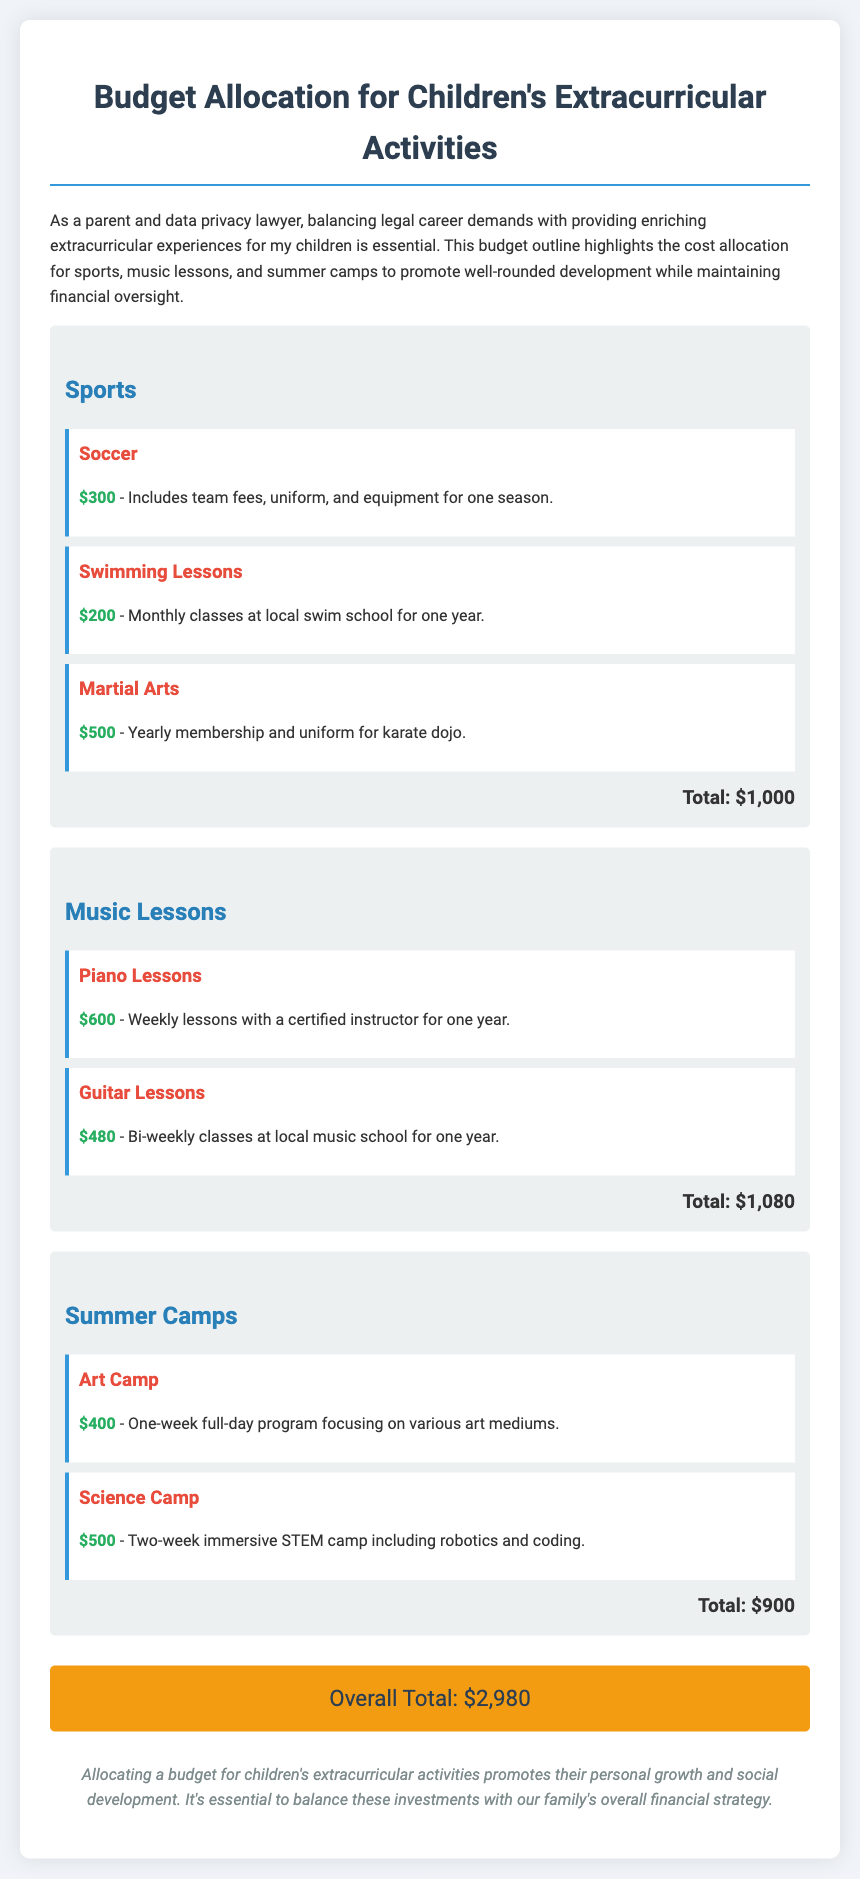What is the total budget for sports? The total budget for sports is summarized at the end of that section, which is $1,000.
Answer: $1,000 How much do piano lessons cost? The cost of piano lessons is clearly stated in the music lessons category, which is $600.
Answer: $600 What is the total cost for summer camps? The total cost for summer camps is indicated at the bottom of the summer camps section, amounting to $900.
Answer: $900 Which extracurricular activity has the highest cost? The activity with the highest cost is martial arts, with a total of $500 for the year.
Answer: Martial Arts What is the overall total budget for all activities? The overall total is calculated by summing the totals from each category, which is $2,980.
Answer: $2,980 How many weeks does the science camp last? The document specifies that the science camp is a two-week program.
Answer: Two weeks What type of sports activity is listed first? The first sports activity listed is soccer.
Answer: Soccer What color is used for the titles of each category? The color used for the titles of each category is a shade of blue, specifically #2980b9.
Answer: Blue How often are guitar lessons held? The frequency of guitar lessons is described as bi-weekly in the document.
Answer: Bi-weekly 